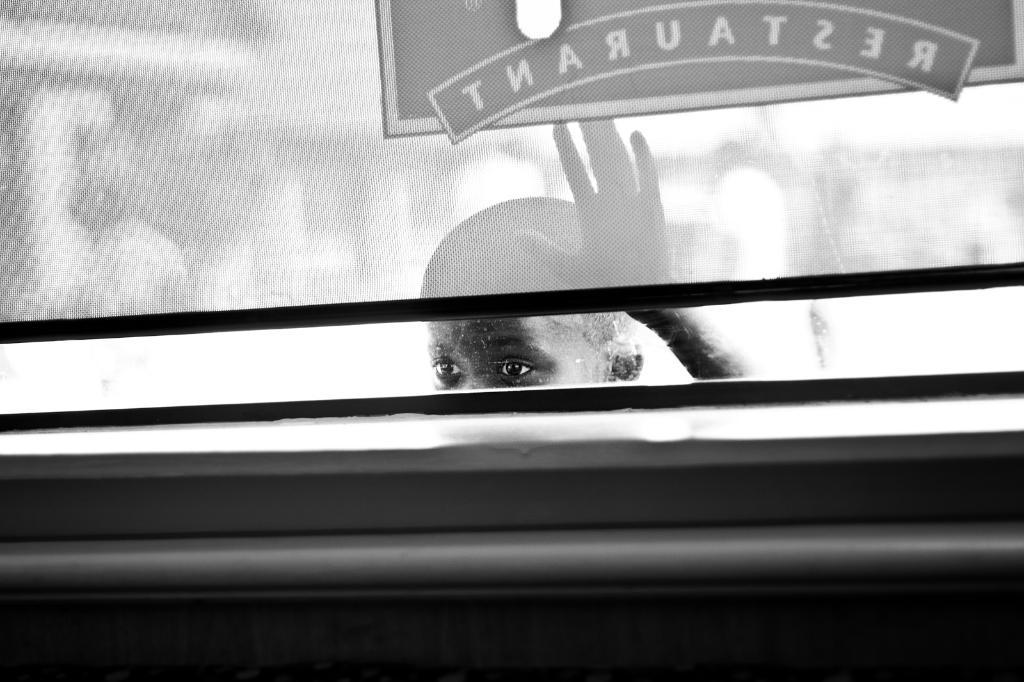Who is present in the image? There is a boy in the image. What is the boy doing in the image? The boy is standing behind a glass wall and looking inside through it. What type of houses can be seen in the image? There are no houses present in the image; it features a boy standing behind a glass wall and looking inside. What scientific discoveries are being made in the image? There is no indication of any scientific activity in the image; it simply shows a boy looking through a glass wall. 